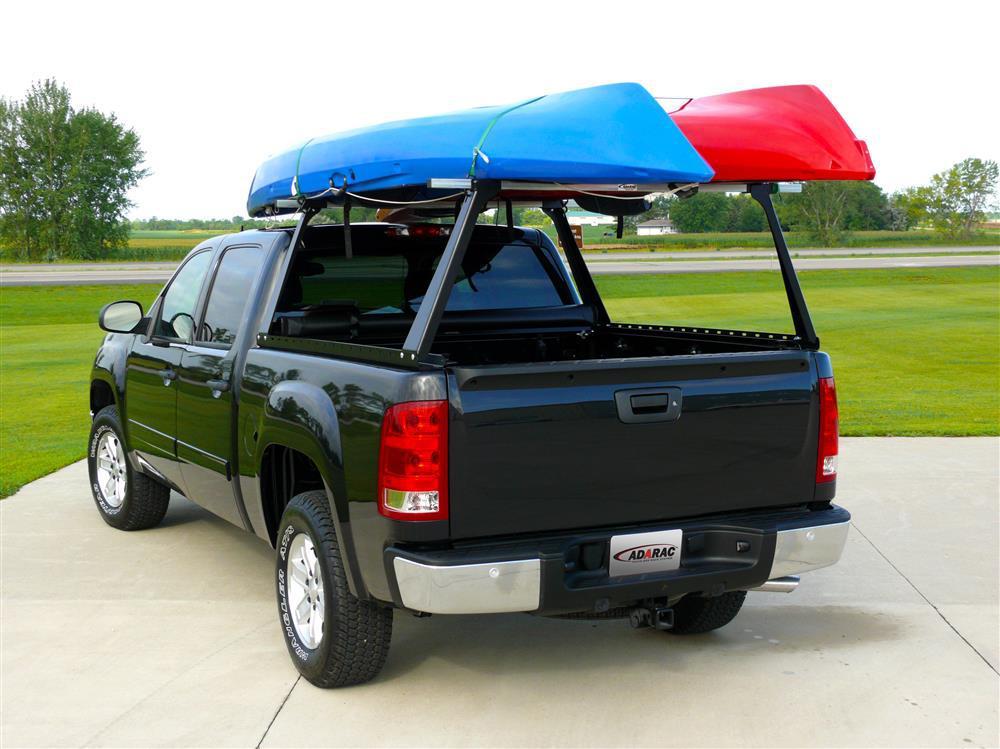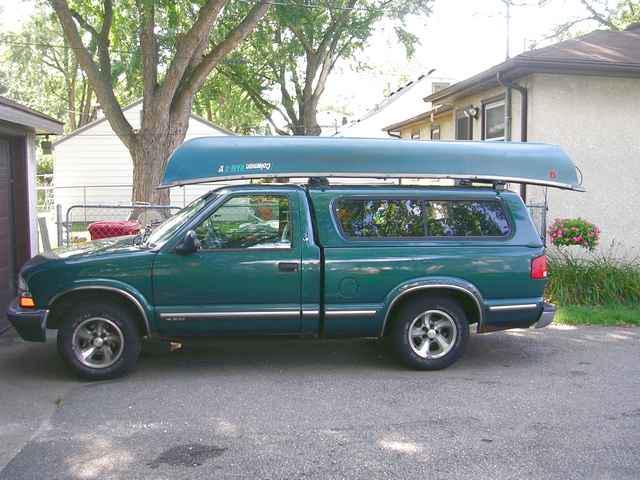The first image is the image on the left, the second image is the image on the right. Given the left and right images, does the statement "A pickup carrying two different colored canoes is heading away from the camera, in one image." hold true? Answer yes or no. Yes. 